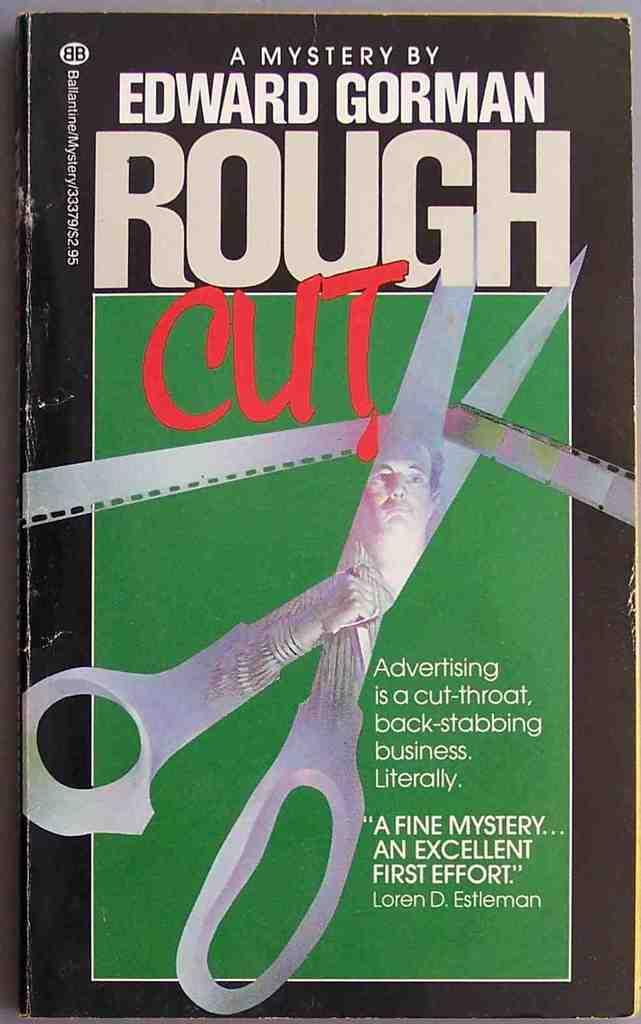<image>
Share a concise interpretation of the image provided. Scissors are on the cover of a mystery by Edward Gorman. 